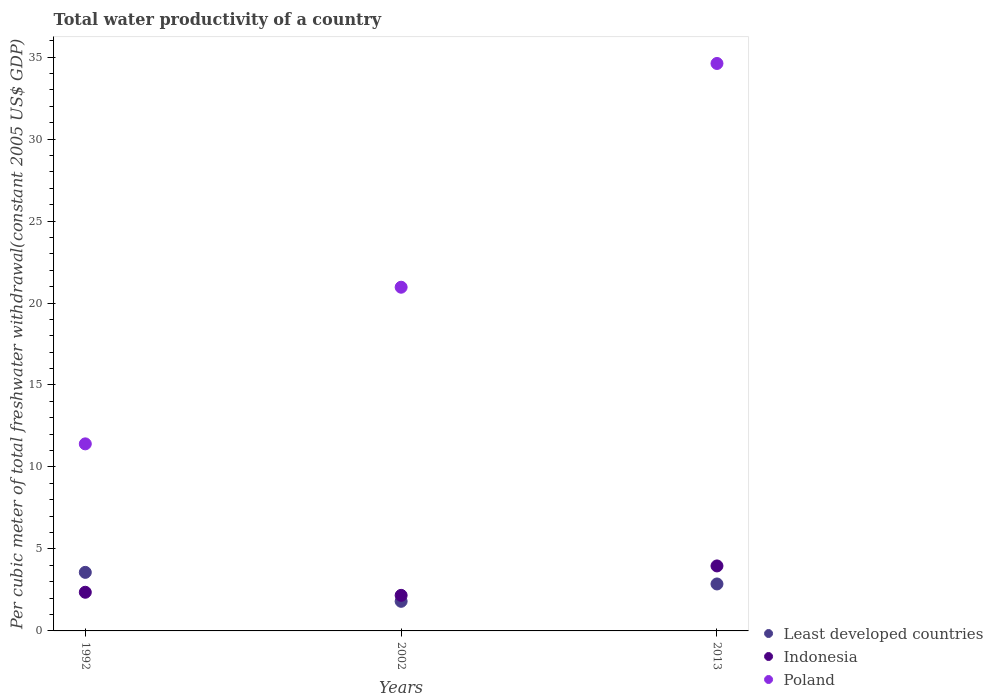What is the total water productivity in Least developed countries in 2013?
Offer a terse response. 2.86. Across all years, what is the maximum total water productivity in Poland?
Offer a terse response. 34.61. Across all years, what is the minimum total water productivity in Indonesia?
Give a very brief answer. 2.17. In which year was the total water productivity in Poland maximum?
Ensure brevity in your answer.  2013. What is the total total water productivity in Poland in the graph?
Your answer should be very brief. 66.98. What is the difference between the total water productivity in Least developed countries in 1992 and that in 2013?
Your response must be concise. 0.71. What is the difference between the total water productivity in Least developed countries in 2002 and the total water productivity in Indonesia in 1992?
Provide a succinct answer. -0.55. What is the average total water productivity in Indonesia per year?
Your answer should be compact. 2.83. In the year 1992, what is the difference between the total water productivity in Least developed countries and total water productivity in Poland?
Ensure brevity in your answer.  -7.84. In how many years, is the total water productivity in Least developed countries greater than 8 US$?
Provide a short and direct response. 0. What is the ratio of the total water productivity in Poland in 1992 to that in 2013?
Ensure brevity in your answer.  0.33. What is the difference between the highest and the second highest total water productivity in Least developed countries?
Offer a terse response. 0.71. What is the difference between the highest and the lowest total water productivity in Least developed countries?
Ensure brevity in your answer.  1.77. In how many years, is the total water productivity in Least developed countries greater than the average total water productivity in Least developed countries taken over all years?
Offer a very short reply. 2. Does the total water productivity in Poland monotonically increase over the years?
Make the answer very short. Yes. Is the total water productivity in Indonesia strictly less than the total water productivity in Least developed countries over the years?
Offer a terse response. No. What is the difference between two consecutive major ticks on the Y-axis?
Offer a very short reply. 5. How are the legend labels stacked?
Ensure brevity in your answer.  Vertical. What is the title of the graph?
Provide a succinct answer. Total water productivity of a country. What is the label or title of the X-axis?
Provide a short and direct response. Years. What is the label or title of the Y-axis?
Ensure brevity in your answer.  Per cubic meter of total freshwater withdrawal(constant 2005 US$ GDP). What is the Per cubic meter of total freshwater withdrawal(constant 2005 US$ GDP) in Least developed countries in 1992?
Keep it short and to the point. 3.57. What is the Per cubic meter of total freshwater withdrawal(constant 2005 US$ GDP) of Indonesia in 1992?
Make the answer very short. 2.36. What is the Per cubic meter of total freshwater withdrawal(constant 2005 US$ GDP) in Poland in 1992?
Make the answer very short. 11.41. What is the Per cubic meter of total freshwater withdrawal(constant 2005 US$ GDP) in Least developed countries in 2002?
Provide a succinct answer. 1.81. What is the Per cubic meter of total freshwater withdrawal(constant 2005 US$ GDP) of Indonesia in 2002?
Offer a very short reply. 2.17. What is the Per cubic meter of total freshwater withdrawal(constant 2005 US$ GDP) in Poland in 2002?
Your answer should be compact. 20.96. What is the Per cubic meter of total freshwater withdrawal(constant 2005 US$ GDP) in Least developed countries in 2013?
Offer a very short reply. 2.86. What is the Per cubic meter of total freshwater withdrawal(constant 2005 US$ GDP) of Indonesia in 2013?
Your answer should be very brief. 3.96. What is the Per cubic meter of total freshwater withdrawal(constant 2005 US$ GDP) of Poland in 2013?
Your response must be concise. 34.61. Across all years, what is the maximum Per cubic meter of total freshwater withdrawal(constant 2005 US$ GDP) of Least developed countries?
Offer a very short reply. 3.57. Across all years, what is the maximum Per cubic meter of total freshwater withdrawal(constant 2005 US$ GDP) in Indonesia?
Offer a very short reply. 3.96. Across all years, what is the maximum Per cubic meter of total freshwater withdrawal(constant 2005 US$ GDP) of Poland?
Ensure brevity in your answer.  34.61. Across all years, what is the minimum Per cubic meter of total freshwater withdrawal(constant 2005 US$ GDP) in Least developed countries?
Your answer should be very brief. 1.81. Across all years, what is the minimum Per cubic meter of total freshwater withdrawal(constant 2005 US$ GDP) in Indonesia?
Your answer should be compact. 2.17. Across all years, what is the minimum Per cubic meter of total freshwater withdrawal(constant 2005 US$ GDP) in Poland?
Your response must be concise. 11.41. What is the total Per cubic meter of total freshwater withdrawal(constant 2005 US$ GDP) of Least developed countries in the graph?
Your answer should be very brief. 8.24. What is the total Per cubic meter of total freshwater withdrawal(constant 2005 US$ GDP) of Indonesia in the graph?
Ensure brevity in your answer.  8.49. What is the total Per cubic meter of total freshwater withdrawal(constant 2005 US$ GDP) in Poland in the graph?
Provide a short and direct response. 66.98. What is the difference between the Per cubic meter of total freshwater withdrawal(constant 2005 US$ GDP) in Least developed countries in 1992 and that in 2002?
Your answer should be very brief. 1.77. What is the difference between the Per cubic meter of total freshwater withdrawal(constant 2005 US$ GDP) of Indonesia in 1992 and that in 2002?
Your answer should be compact. 0.19. What is the difference between the Per cubic meter of total freshwater withdrawal(constant 2005 US$ GDP) in Poland in 1992 and that in 2002?
Ensure brevity in your answer.  -9.55. What is the difference between the Per cubic meter of total freshwater withdrawal(constant 2005 US$ GDP) of Least developed countries in 1992 and that in 2013?
Make the answer very short. 0.71. What is the difference between the Per cubic meter of total freshwater withdrawal(constant 2005 US$ GDP) of Indonesia in 1992 and that in 2013?
Make the answer very short. -1.61. What is the difference between the Per cubic meter of total freshwater withdrawal(constant 2005 US$ GDP) in Poland in 1992 and that in 2013?
Ensure brevity in your answer.  -23.2. What is the difference between the Per cubic meter of total freshwater withdrawal(constant 2005 US$ GDP) of Least developed countries in 2002 and that in 2013?
Provide a short and direct response. -1.06. What is the difference between the Per cubic meter of total freshwater withdrawal(constant 2005 US$ GDP) in Indonesia in 2002 and that in 2013?
Offer a very short reply. -1.79. What is the difference between the Per cubic meter of total freshwater withdrawal(constant 2005 US$ GDP) in Poland in 2002 and that in 2013?
Give a very brief answer. -13.65. What is the difference between the Per cubic meter of total freshwater withdrawal(constant 2005 US$ GDP) of Least developed countries in 1992 and the Per cubic meter of total freshwater withdrawal(constant 2005 US$ GDP) of Indonesia in 2002?
Offer a very short reply. 1.4. What is the difference between the Per cubic meter of total freshwater withdrawal(constant 2005 US$ GDP) in Least developed countries in 1992 and the Per cubic meter of total freshwater withdrawal(constant 2005 US$ GDP) in Poland in 2002?
Give a very brief answer. -17.39. What is the difference between the Per cubic meter of total freshwater withdrawal(constant 2005 US$ GDP) of Indonesia in 1992 and the Per cubic meter of total freshwater withdrawal(constant 2005 US$ GDP) of Poland in 2002?
Keep it short and to the point. -18.6. What is the difference between the Per cubic meter of total freshwater withdrawal(constant 2005 US$ GDP) of Least developed countries in 1992 and the Per cubic meter of total freshwater withdrawal(constant 2005 US$ GDP) of Indonesia in 2013?
Your answer should be compact. -0.39. What is the difference between the Per cubic meter of total freshwater withdrawal(constant 2005 US$ GDP) of Least developed countries in 1992 and the Per cubic meter of total freshwater withdrawal(constant 2005 US$ GDP) of Poland in 2013?
Give a very brief answer. -31.04. What is the difference between the Per cubic meter of total freshwater withdrawal(constant 2005 US$ GDP) of Indonesia in 1992 and the Per cubic meter of total freshwater withdrawal(constant 2005 US$ GDP) of Poland in 2013?
Your answer should be compact. -32.25. What is the difference between the Per cubic meter of total freshwater withdrawal(constant 2005 US$ GDP) of Least developed countries in 2002 and the Per cubic meter of total freshwater withdrawal(constant 2005 US$ GDP) of Indonesia in 2013?
Offer a terse response. -2.16. What is the difference between the Per cubic meter of total freshwater withdrawal(constant 2005 US$ GDP) of Least developed countries in 2002 and the Per cubic meter of total freshwater withdrawal(constant 2005 US$ GDP) of Poland in 2013?
Your answer should be very brief. -32.8. What is the difference between the Per cubic meter of total freshwater withdrawal(constant 2005 US$ GDP) in Indonesia in 2002 and the Per cubic meter of total freshwater withdrawal(constant 2005 US$ GDP) in Poland in 2013?
Your answer should be compact. -32.44. What is the average Per cubic meter of total freshwater withdrawal(constant 2005 US$ GDP) in Least developed countries per year?
Ensure brevity in your answer.  2.75. What is the average Per cubic meter of total freshwater withdrawal(constant 2005 US$ GDP) in Indonesia per year?
Give a very brief answer. 2.83. What is the average Per cubic meter of total freshwater withdrawal(constant 2005 US$ GDP) in Poland per year?
Provide a succinct answer. 22.33. In the year 1992, what is the difference between the Per cubic meter of total freshwater withdrawal(constant 2005 US$ GDP) in Least developed countries and Per cubic meter of total freshwater withdrawal(constant 2005 US$ GDP) in Indonesia?
Ensure brevity in your answer.  1.21. In the year 1992, what is the difference between the Per cubic meter of total freshwater withdrawal(constant 2005 US$ GDP) of Least developed countries and Per cubic meter of total freshwater withdrawal(constant 2005 US$ GDP) of Poland?
Ensure brevity in your answer.  -7.84. In the year 1992, what is the difference between the Per cubic meter of total freshwater withdrawal(constant 2005 US$ GDP) of Indonesia and Per cubic meter of total freshwater withdrawal(constant 2005 US$ GDP) of Poland?
Keep it short and to the point. -9.05. In the year 2002, what is the difference between the Per cubic meter of total freshwater withdrawal(constant 2005 US$ GDP) of Least developed countries and Per cubic meter of total freshwater withdrawal(constant 2005 US$ GDP) of Indonesia?
Your response must be concise. -0.36. In the year 2002, what is the difference between the Per cubic meter of total freshwater withdrawal(constant 2005 US$ GDP) of Least developed countries and Per cubic meter of total freshwater withdrawal(constant 2005 US$ GDP) of Poland?
Provide a short and direct response. -19.16. In the year 2002, what is the difference between the Per cubic meter of total freshwater withdrawal(constant 2005 US$ GDP) of Indonesia and Per cubic meter of total freshwater withdrawal(constant 2005 US$ GDP) of Poland?
Make the answer very short. -18.79. In the year 2013, what is the difference between the Per cubic meter of total freshwater withdrawal(constant 2005 US$ GDP) in Least developed countries and Per cubic meter of total freshwater withdrawal(constant 2005 US$ GDP) in Indonesia?
Provide a short and direct response. -1.1. In the year 2013, what is the difference between the Per cubic meter of total freshwater withdrawal(constant 2005 US$ GDP) of Least developed countries and Per cubic meter of total freshwater withdrawal(constant 2005 US$ GDP) of Poland?
Your response must be concise. -31.75. In the year 2013, what is the difference between the Per cubic meter of total freshwater withdrawal(constant 2005 US$ GDP) of Indonesia and Per cubic meter of total freshwater withdrawal(constant 2005 US$ GDP) of Poland?
Offer a very short reply. -30.65. What is the ratio of the Per cubic meter of total freshwater withdrawal(constant 2005 US$ GDP) in Least developed countries in 1992 to that in 2002?
Provide a succinct answer. 1.98. What is the ratio of the Per cubic meter of total freshwater withdrawal(constant 2005 US$ GDP) in Indonesia in 1992 to that in 2002?
Give a very brief answer. 1.09. What is the ratio of the Per cubic meter of total freshwater withdrawal(constant 2005 US$ GDP) in Poland in 1992 to that in 2002?
Provide a succinct answer. 0.54. What is the ratio of the Per cubic meter of total freshwater withdrawal(constant 2005 US$ GDP) of Least developed countries in 1992 to that in 2013?
Provide a succinct answer. 1.25. What is the ratio of the Per cubic meter of total freshwater withdrawal(constant 2005 US$ GDP) of Indonesia in 1992 to that in 2013?
Your response must be concise. 0.59. What is the ratio of the Per cubic meter of total freshwater withdrawal(constant 2005 US$ GDP) of Poland in 1992 to that in 2013?
Your response must be concise. 0.33. What is the ratio of the Per cubic meter of total freshwater withdrawal(constant 2005 US$ GDP) of Least developed countries in 2002 to that in 2013?
Provide a short and direct response. 0.63. What is the ratio of the Per cubic meter of total freshwater withdrawal(constant 2005 US$ GDP) of Indonesia in 2002 to that in 2013?
Your answer should be compact. 0.55. What is the ratio of the Per cubic meter of total freshwater withdrawal(constant 2005 US$ GDP) of Poland in 2002 to that in 2013?
Your answer should be compact. 0.61. What is the difference between the highest and the second highest Per cubic meter of total freshwater withdrawal(constant 2005 US$ GDP) of Least developed countries?
Ensure brevity in your answer.  0.71. What is the difference between the highest and the second highest Per cubic meter of total freshwater withdrawal(constant 2005 US$ GDP) in Indonesia?
Your response must be concise. 1.61. What is the difference between the highest and the second highest Per cubic meter of total freshwater withdrawal(constant 2005 US$ GDP) in Poland?
Your answer should be very brief. 13.65. What is the difference between the highest and the lowest Per cubic meter of total freshwater withdrawal(constant 2005 US$ GDP) in Least developed countries?
Keep it short and to the point. 1.77. What is the difference between the highest and the lowest Per cubic meter of total freshwater withdrawal(constant 2005 US$ GDP) in Indonesia?
Your answer should be compact. 1.79. What is the difference between the highest and the lowest Per cubic meter of total freshwater withdrawal(constant 2005 US$ GDP) of Poland?
Offer a terse response. 23.2. 